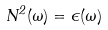Convert formula to latex. <formula><loc_0><loc_0><loc_500><loc_500>N ^ { 2 } ( \omega ) = \epsilon ( \omega )</formula> 